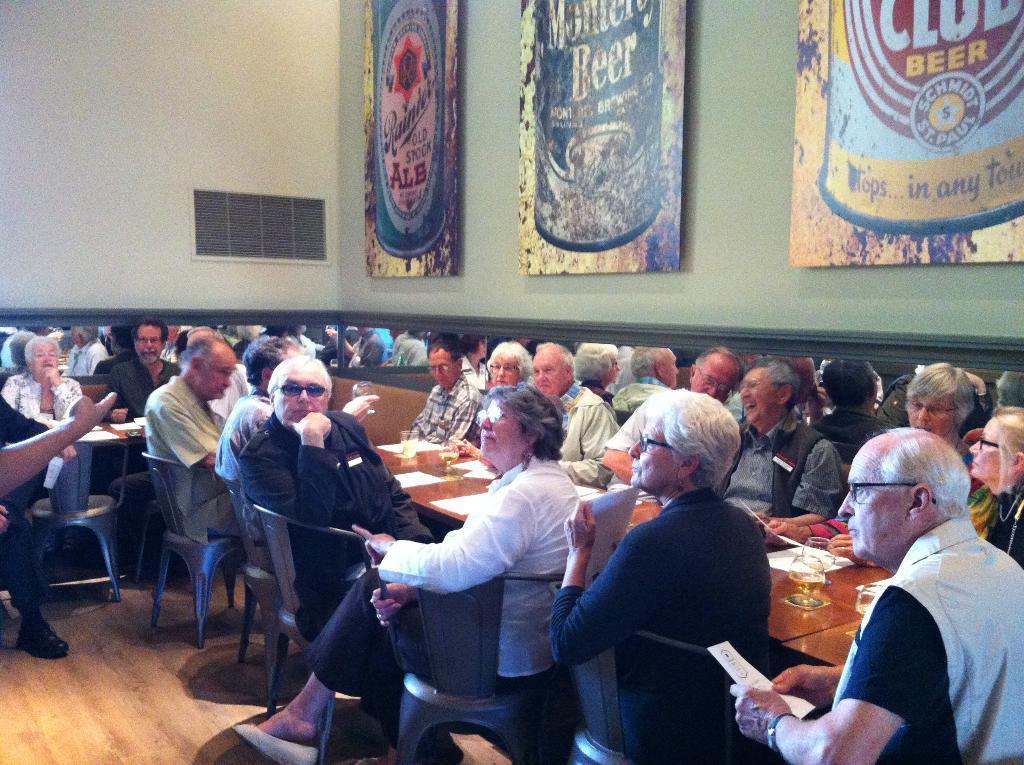Could you give a brief overview of what you see in this image? In this image I can see number of persons sitting on chairs in front of a tables and on the tables I can see few wine glasses and few papers. In the background I can see the wall, the vent and few banners attached to the wall. 